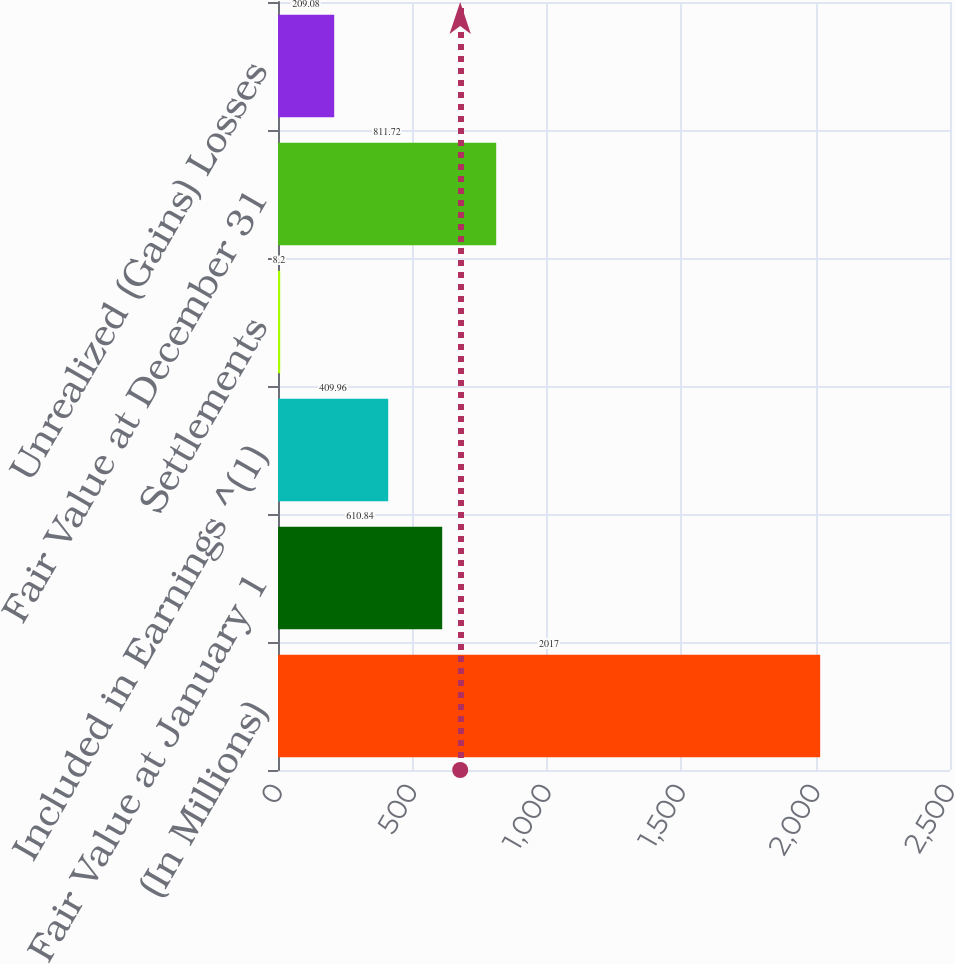<chart> <loc_0><loc_0><loc_500><loc_500><bar_chart><fcel>(In Millions)<fcel>Fair Value at January 1<fcel>Included in Earnings ^(1)<fcel>Settlements<fcel>Fair Value at December 31<fcel>Unrealized (Gains) Losses<nl><fcel>2017<fcel>610.84<fcel>409.96<fcel>8.2<fcel>811.72<fcel>209.08<nl></chart> 